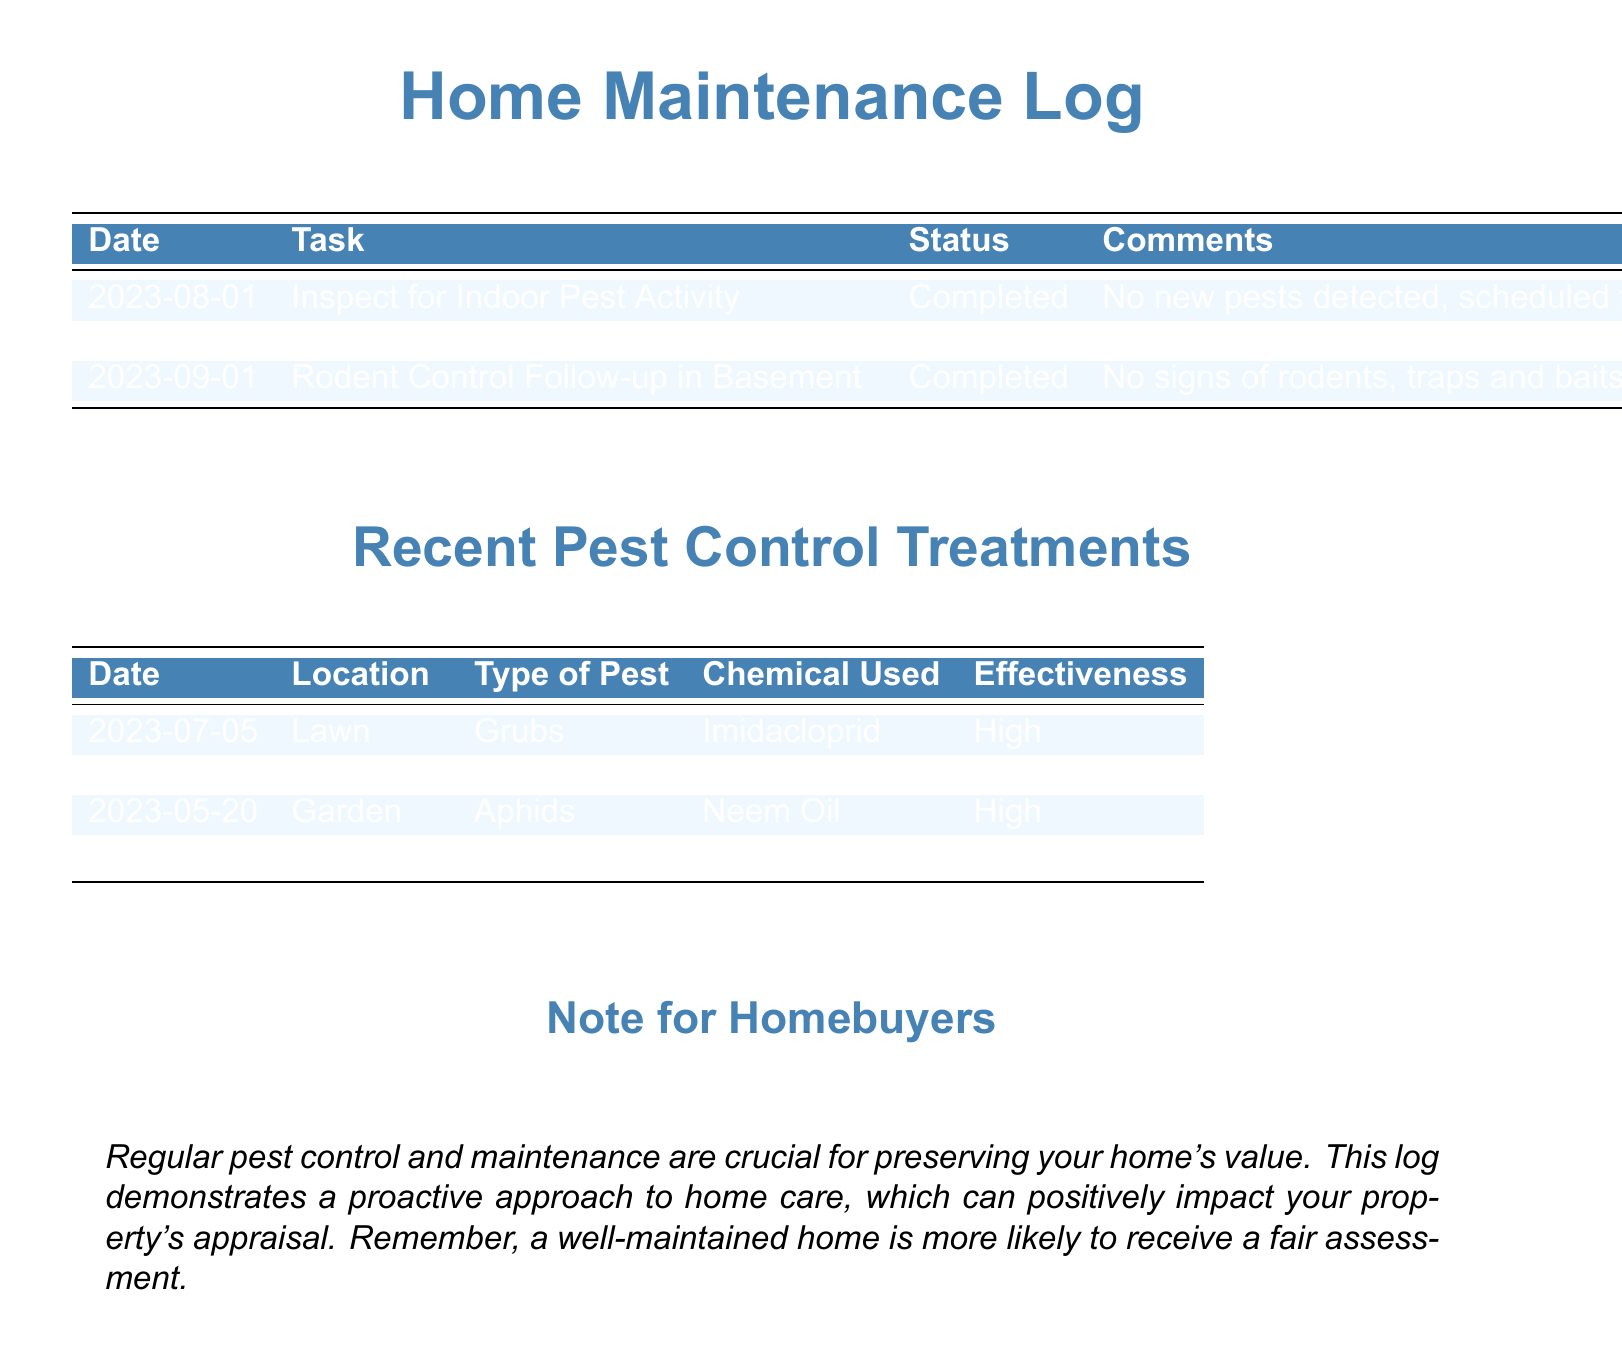What was the last pest treatment performed? The last pest treatment documented was for grubs in the lawn on July 5, 2023.
Answer: Grubs What chemical was used to treat aphids? The document states that Neem Oil was used for treating aphids on May 20, 2023.
Answer: Neem Oil How effective was the treatment for mosquitoes? According to the document, the effectiveness of the treatment for mosquitoes was moderate.
Answer: Moderate What date was the rodent control follow-up completed? The last check for rodent control was completed on September 1, 2023.
Answer: September 1, 2023 Which pests had a high effectiveness rating for their treatments? The treatments for grubs, aphids, and rodents all had a high effectiveness rating.
Answer: Grubs, aphids, rodents How many times was Neem Oil used according to the log? Neem Oil was used once for treating aphids on May 20, 2023.
Answer: Once What is the significance of regular pest control for homebuyers? The note for homebuyers emphasizes that regular pest control is crucial for preserving home value and can positively impact property appraisal.
Answer: Preserving home value What task is scheduled for quarterly checks? The inspection for indoor pest activity is scheduled for quarterly checks.
Answer: Inspect for Indoor Pest Activity When was the last treatment for mosquitoes? The last treatment for mosquitoes was done on June 15, 2023.
Answer: June 15, 2023 